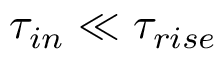<formula> <loc_0><loc_0><loc_500><loc_500>\tau _ { i n } \ll \tau _ { r i s e }</formula> 